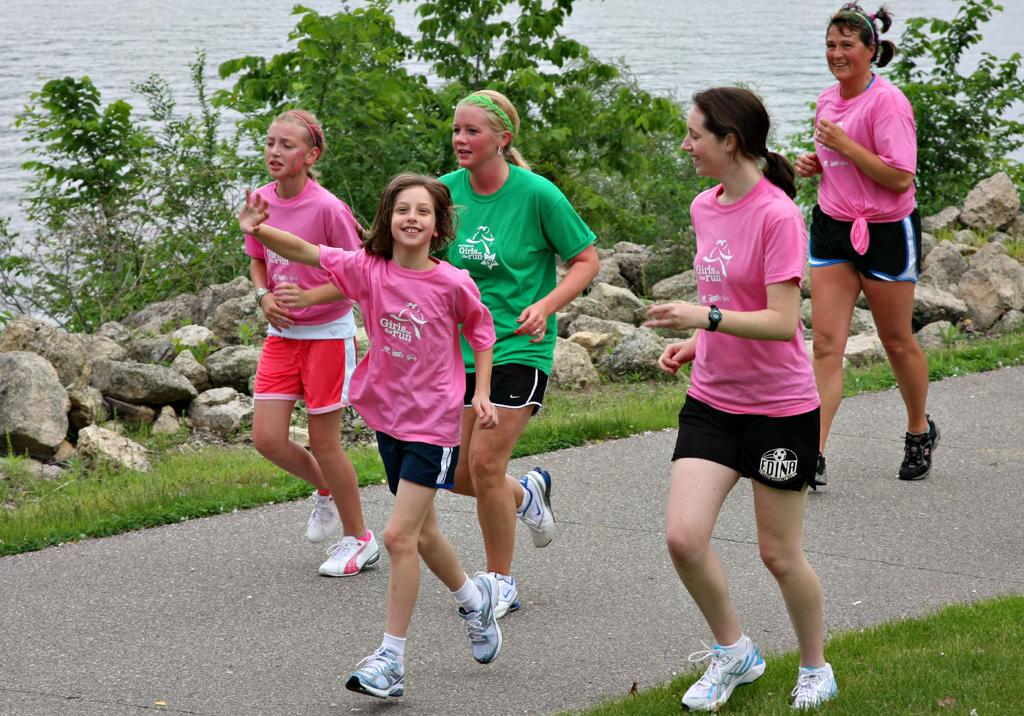What is happening in the center of the image? There are people in the center of the image, and they appear to be running. What can be seen in the background of the image? There are rocks, plants, and water visible in the background of the image. What type of mine is present in the image? There is no mine present in the image; it features people running and a background with rocks, plants, and water. 